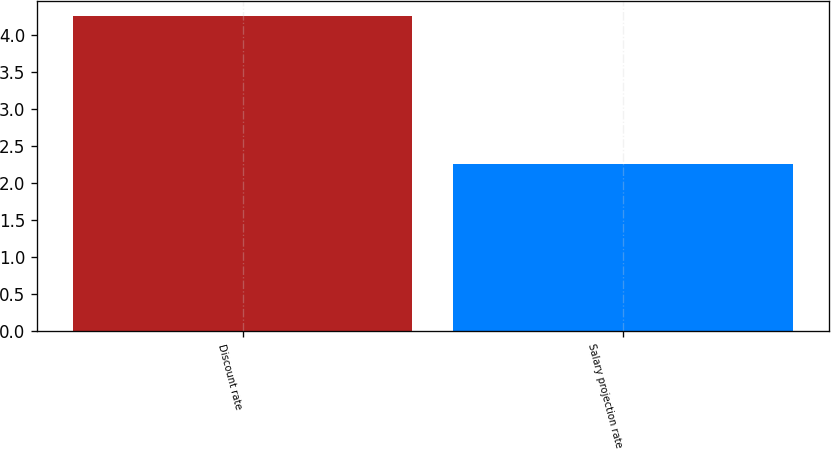Convert chart. <chart><loc_0><loc_0><loc_500><loc_500><bar_chart><fcel>Discount rate<fcel>Salary projection rate<nl><fcel>4.25<fcel>2.25<nl></chart> 